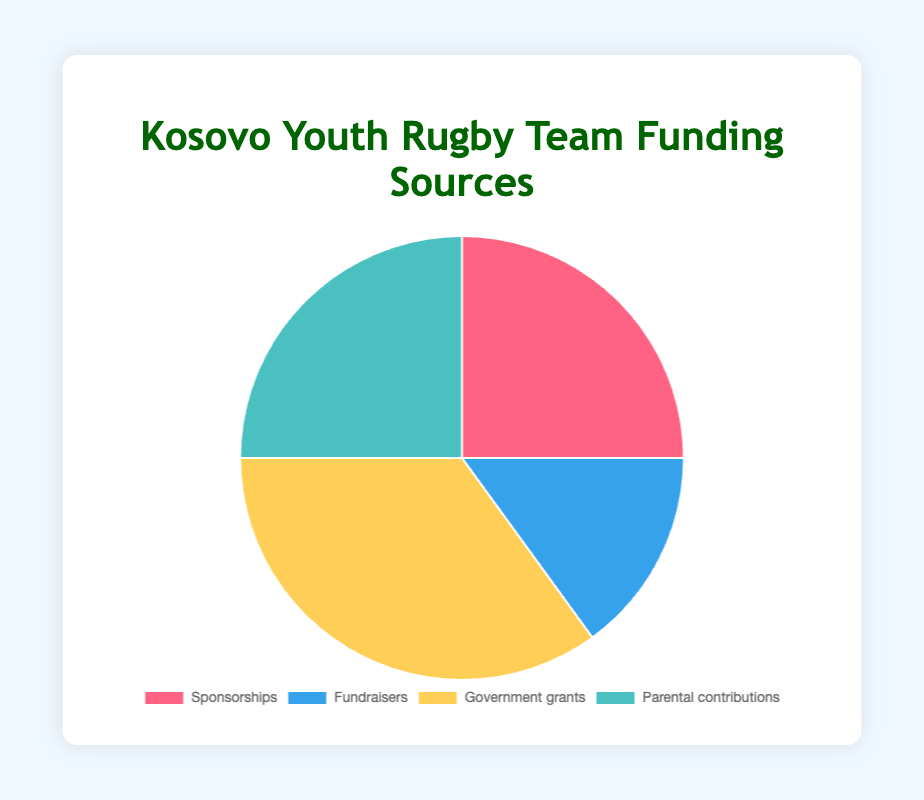What percentage of the team's funding comes from private sources (Sponsorships and Parental contributions)? Add the percentages for Sponsorships and Parental contributions: 25% + 25% = 50%
Answer: 50% Which funding source provides the largest percentage of the team's funding? Compare the percentages of all funding sources and see which is the largest. The largest percentage is 35%, which comes from Government grants.
Answer: Government grants If the team wanted to distribute funding equally among all sources, how much percentage would each source get? Divide 100% by the number of funding sources (4): 100% / 4 = 25%
Answer: 25% How much more does Government grants contribute compared to Fundraisers? Subtract the percentage of Fundraisers from Government grants: 35% - 15% = 20%
Answer: 20% Which segments in the pie chart are of the same size? Look for segments with equal percentages in the pie chart. Both Sponsorships and Parental contributions have 25% each.
Answer: Sponsorships and Parental contributions What is the difference in percentage between the largest and smallest funding sources? Subtract the smallest percentage (Fundraisers at 15%) from the largest percentage (Government grants at 35%): 35% - 15% = 20%
Answer: 20% If Fundraisers increased by 10%, what would be its new percentage? Add 10% to the original percentage of Fundraisers: 15% + 10% = 25%
Answer: 25% If Parental contributions were doubled, what would be its new percentage? Multiply the percentage of Parental contributions by 2: 25% * 2 = 50%
Answer: 50% What source contributes the same percentage as Sponsorships? Compare the percentage of Sponsorships (25%) with other sources. Parental contributions also contribute 25%.
Answer: Parental contributions 